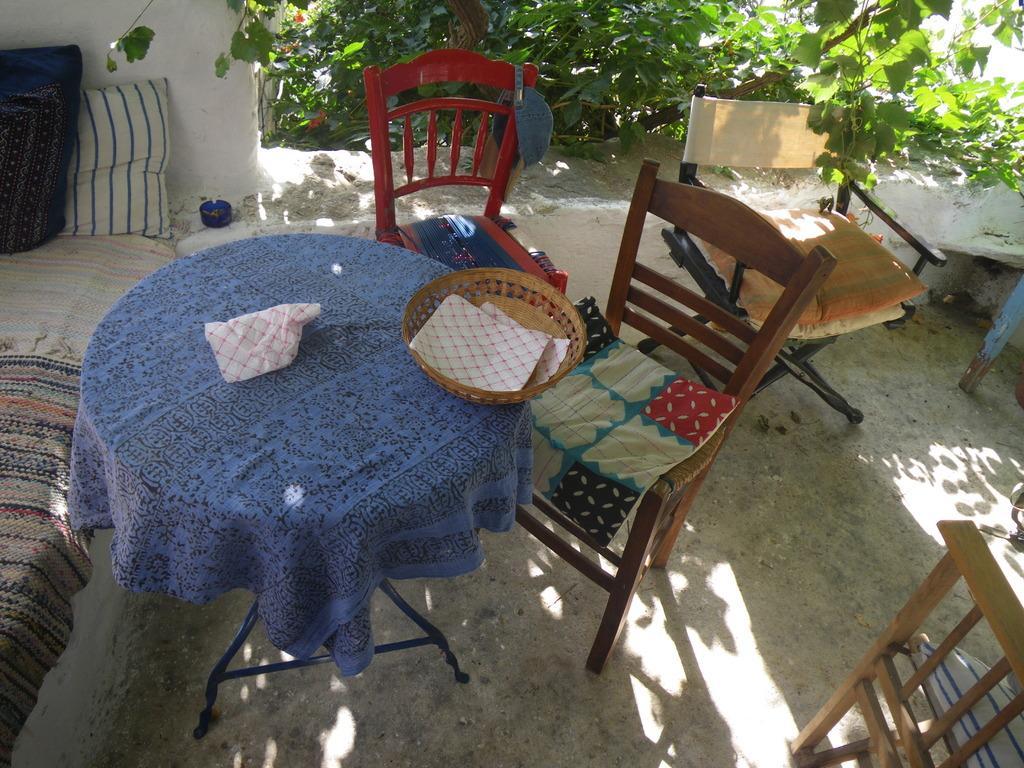Could you give a brief overview of what you see in this image? In the picture I can see a bed which has two pillows placed on it in the left corner and there is a table which has few objects placed on it is beside it and there are few chairs placed beside the table and there are few plants in the background. 